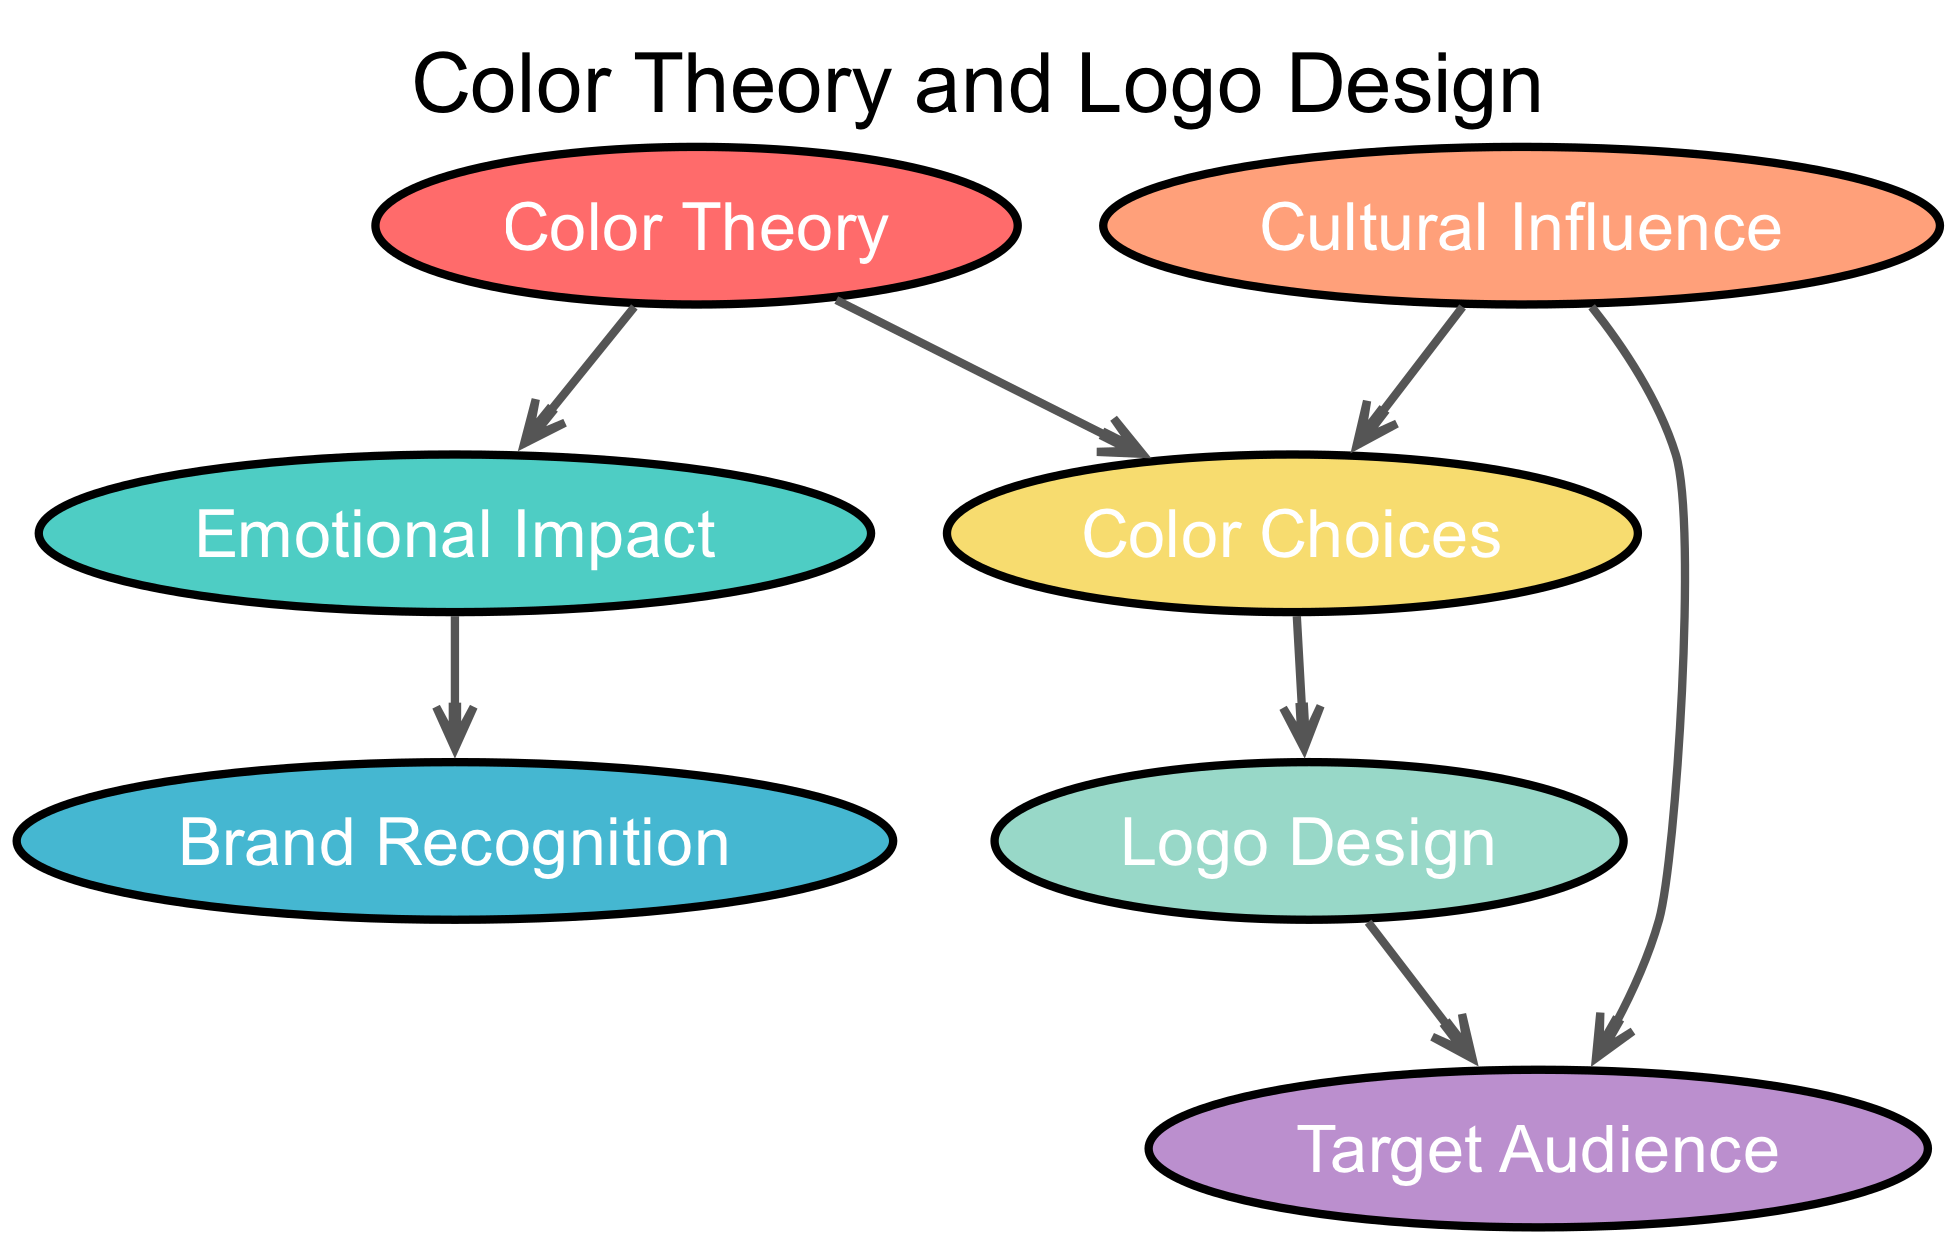What is the total number of nodes in the diagram? The diagram lists six nodes: Color Theory, Emotional Impact, Brand Recognition, Cultural Influence, Logo Design, and Color Choices. Counting these provides the total number of nodes.
Answer: 7 Which node directly influences Brand Recognition? The direct edge from Emotional Impact to Brand Recognition indicates that Emotional Impact influences Brand Recognition. Thus, Emotional Impact is responsible for this relationship.
Answer: Emotional Impact What color choices are influenced by Cultural Influence? The edge from Cultural Influence to Color Choices illustrates that Cultural Influence affects Color Choices. This indicates that Cultural context or cultural background shapes the color options chosen for a logo.
Answer: Color Choices How many edges are present in the diagram? The diagram outlines a total of six edges connecting the nodes which represent the relationships between them. Counting these edges results in the total number.
Answer: 6 Which two nodes are connected through the edge that involves Logo Design? The diagram shows an edge going from Color Choices to Logo Design. This means that the relationship between these two nodes is established through this connection, indicating that Color Choices impact the design of logos.
Answer: Color Choices and Logo Design Which node relates to both Target Audience and Color Choices? The Cultural Influence node has edges leading to both Target Audience and Color Choices, signifying its relationship with both concepts. This shows that cultural aspects can influence both the color scheme and the intended audience of a logo.
Answer: Cultural Influence How does Color Theory impact Color Choices? There is a direct edge from Color Theory to Color Choices, illustrating that principles of Color Theory inform and dictate the decisions made regarding Color Choices in branding and logo design.
Answer: Color Choices 